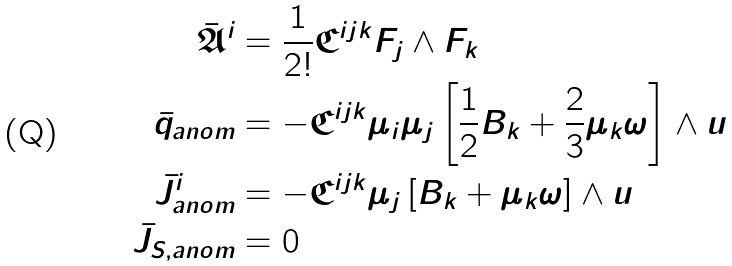Convert formula to latex. <formula><loc_0><loc_0><loc_500><loc_500>\bar { \mathfrak { A } } ^ { i } & = \frac { 1 } { 2 ! } \mathfrak { C } ^ { i j k } F _ { j } \wedge F _ { k } \\ \bar { q } _ { a n o m } & = - \mathfrak { C } ^ { i j k } \mu _ { i } \mu _ { j } \left [ \frac { 1 } { 2 } B _ { k } + \frac { 2 } { 3 } \mu _ { k } \omega \right ] \wedge u \\ \bar { J } ^ { i } _ { a n o m } & = - \mathfrak { C } ^ { i j k } \mu _ { j } \left [ B _ { k } + \mu _ { k } \omega \right ] \wedge u \\ \bar { J } _ { S , a n o m } & = 0</formula> 